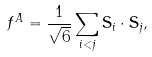Convert formula to latex. <formula><loc_0><loc_0><loc_500><loc_500>f ^ { A } = \frac { 1 } { \sqrt { 6 } } \sum _ { i < j } \mathbf S _ { i } \cdot \mathbf S _ { j } ,</formula> 